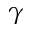Convert formula to latex. <formula><loc_0><loc_0><loc_500><loc_500>\gamma</formula> 